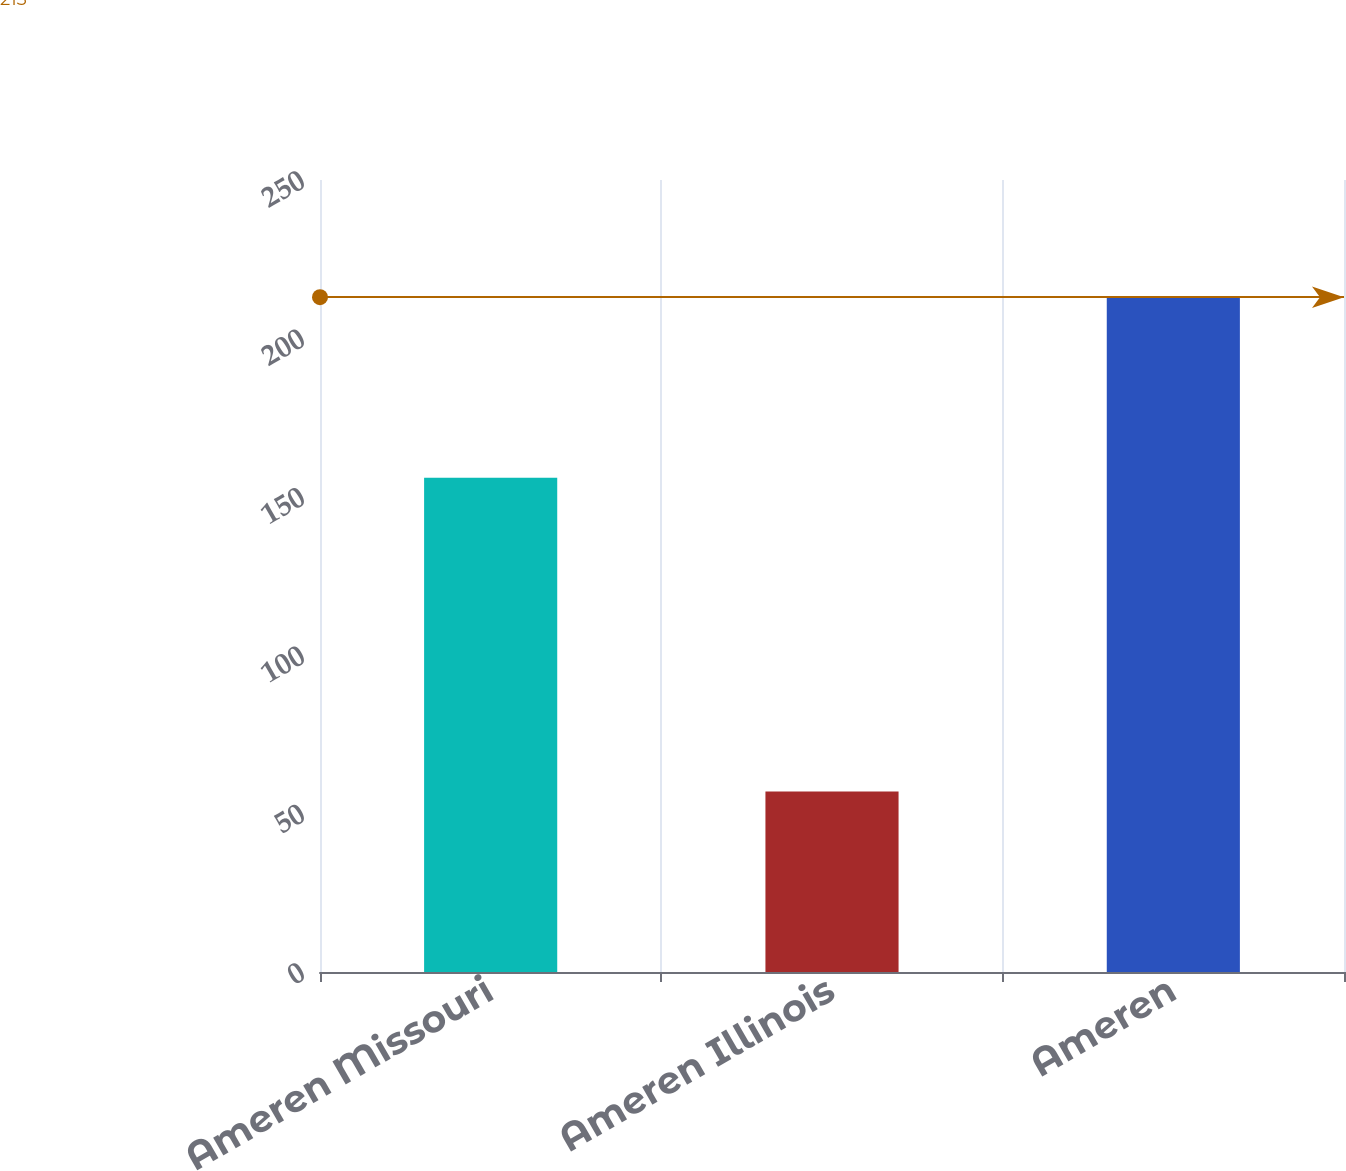<chart> <loc_0><loc_0><loc_500><loc_500><bar_chart><fcel>Ameren Missouri<fcel>Ameren Illinois<fcel>Ameren<nl><fcel>156<fcel>57<fcel>213<nl></chart> 